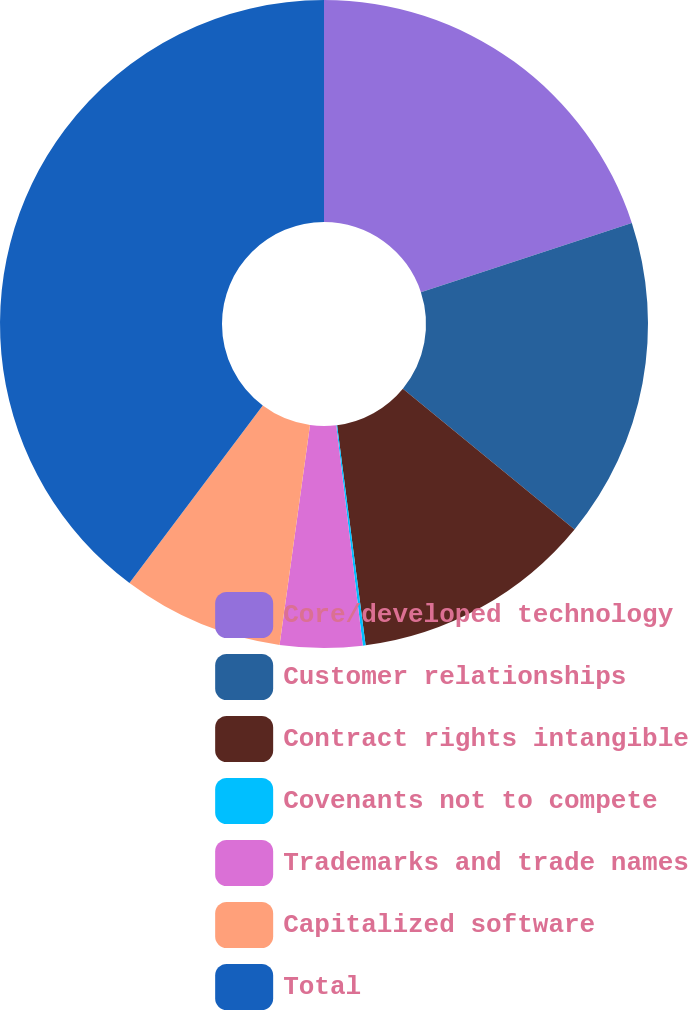Convert chart. <chart><loc_0><loc_0><loc_500><loc_500><pie_chart><fcel>Core/developed technology<fcel>Customer relationships<fcel>Contract rights intangible<fcel>Covenants not to compete<fcel>Trademarks and trade names<fcel>Capitalized software<fcel>Total<nl><fcel>19.95%<fcel>15.98%<fcel>12.02%<fcel>0.14%<fcel>4.1%<fcel>8.06%<fcel>39.75%<nl></chart> 